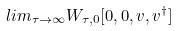<formula> <loc_0><loc_0><loc_500><loc_500>l i m _ { \tau \rightarrow \infty } W _ { \tau , 0 } [ 0 , 0 , v , v ^ { \dagger } ]</formula> 